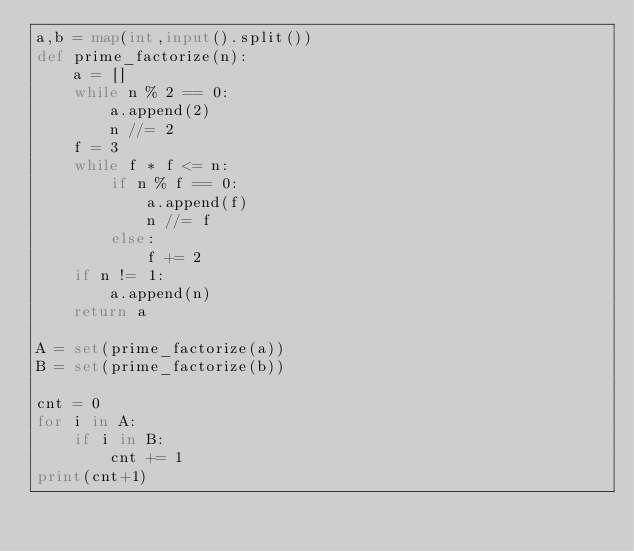Convert code to text. <code><loc_0><loc_0><loc_500><loc_500><_Python_>a,b = map(int,input().split())
def prime_factorize(n):
    a = []
    while n % 2 == 0:
        a.append(2)
        n //= 2
    f = 3
    while f * f <= n:
        if n % f == 0:
            a.append(f)
            n //= f
        else:
            f += 2
    if n != 1:
        a.append(n)
    return a

A = set(prime_factorize(a))
B = set(prime_factorize(b))

cnt = 0
for i in A:
    if i in B:
        cnt += 1
print(cnt+1)</code> 